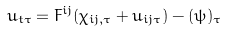<formula> <loc_0><loc_0><loc_500><loc_500>u _ { t \tau } = F ^ { i j } ( \chi _ { i j , \tau } + u _ { i j \tau } ) - ( \psi ) _ { \tau }</formula> 